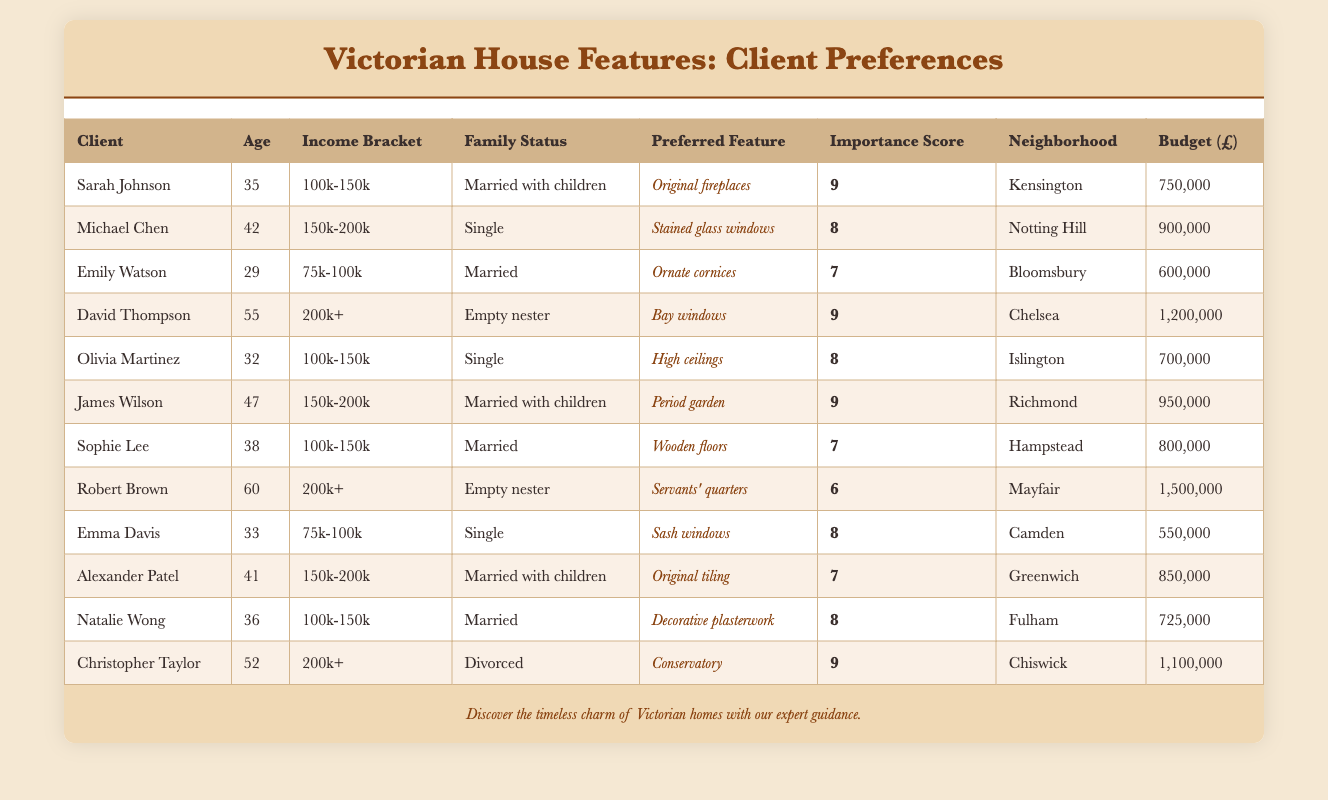What is the highest importance score and who has it? The table shows the importance scores for various clients. By scanning through the Importance Score column, I can see that the highest score is 9, held by Sarah Johnson, David Thompson, James Wilson, and Christopher Taylor.
Answer: 9, Sarah Johnson, David Thompson, James Wilson, Christopher Taylor Which neighborhood has the highest budget? In the Budget column, I look for the maximum value. The highest budget in the table is 1,500,000 from Robert Brown, located in Mayfair.
Answer: 1,500,000, Mayfair What is the average importance score for clients with a family status of "Married with children"? To calculate the average, I first identify the importance scores for clients with this family status: Sarah Johnson (9), James Wilson (9), and Alexander Patel (7). Then, sum these scores: 9 + 9 + 7 = 25. There are 3 clients, so the average is 25 / 3 = 8.33.
Answer: 8.33 Are there any clients whose preferred feature includes windows? Looking in the Preferred Feature column, I see that several clients mention windows: Michael Chen (Stained glass windows), Olivia Martinez (High ceilings), and Emma Davis (Sash windows). This confirms there are clients with window features.
Answer: Yes How many clients in their 30s prefer original fireplaces or bay windows? I examine the Age column for clients aged 30 to 39. The relevant clients are Sarah Johnson (35) and Olivia Martinez (32) for the original fireplace, and David Thompson (55) for bay windows. Only Sarah Johnson prefers the original fireplace, thus there is one client meeting the initial criteria for fireplaces or bay windows.
Answer: 1 